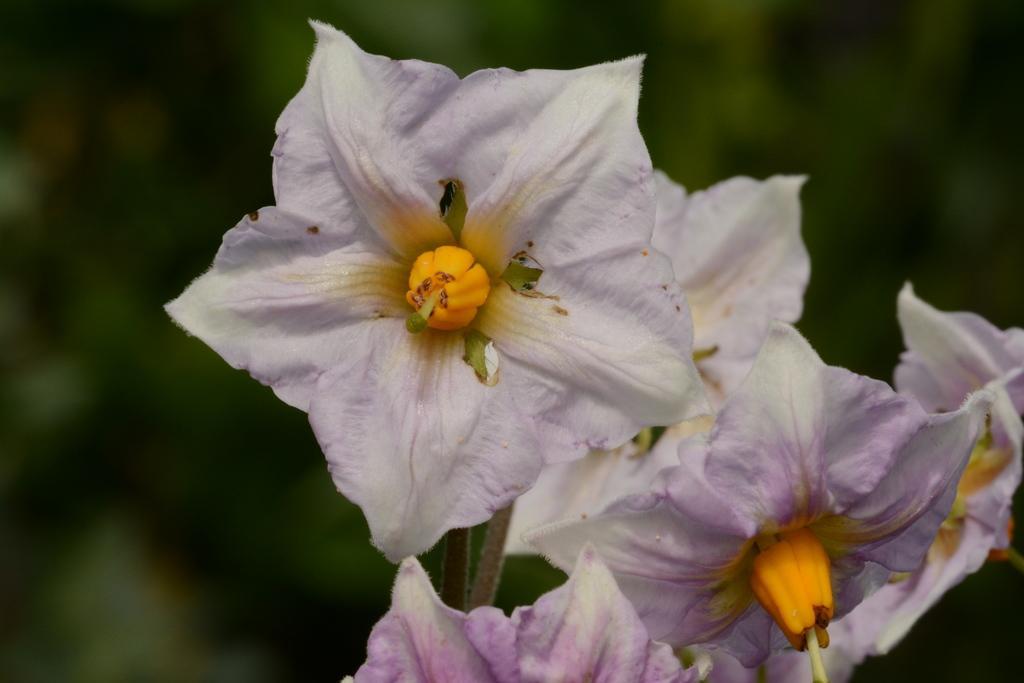Describe this image in one or two sentences. This image consists of flowers. They are in white color. 